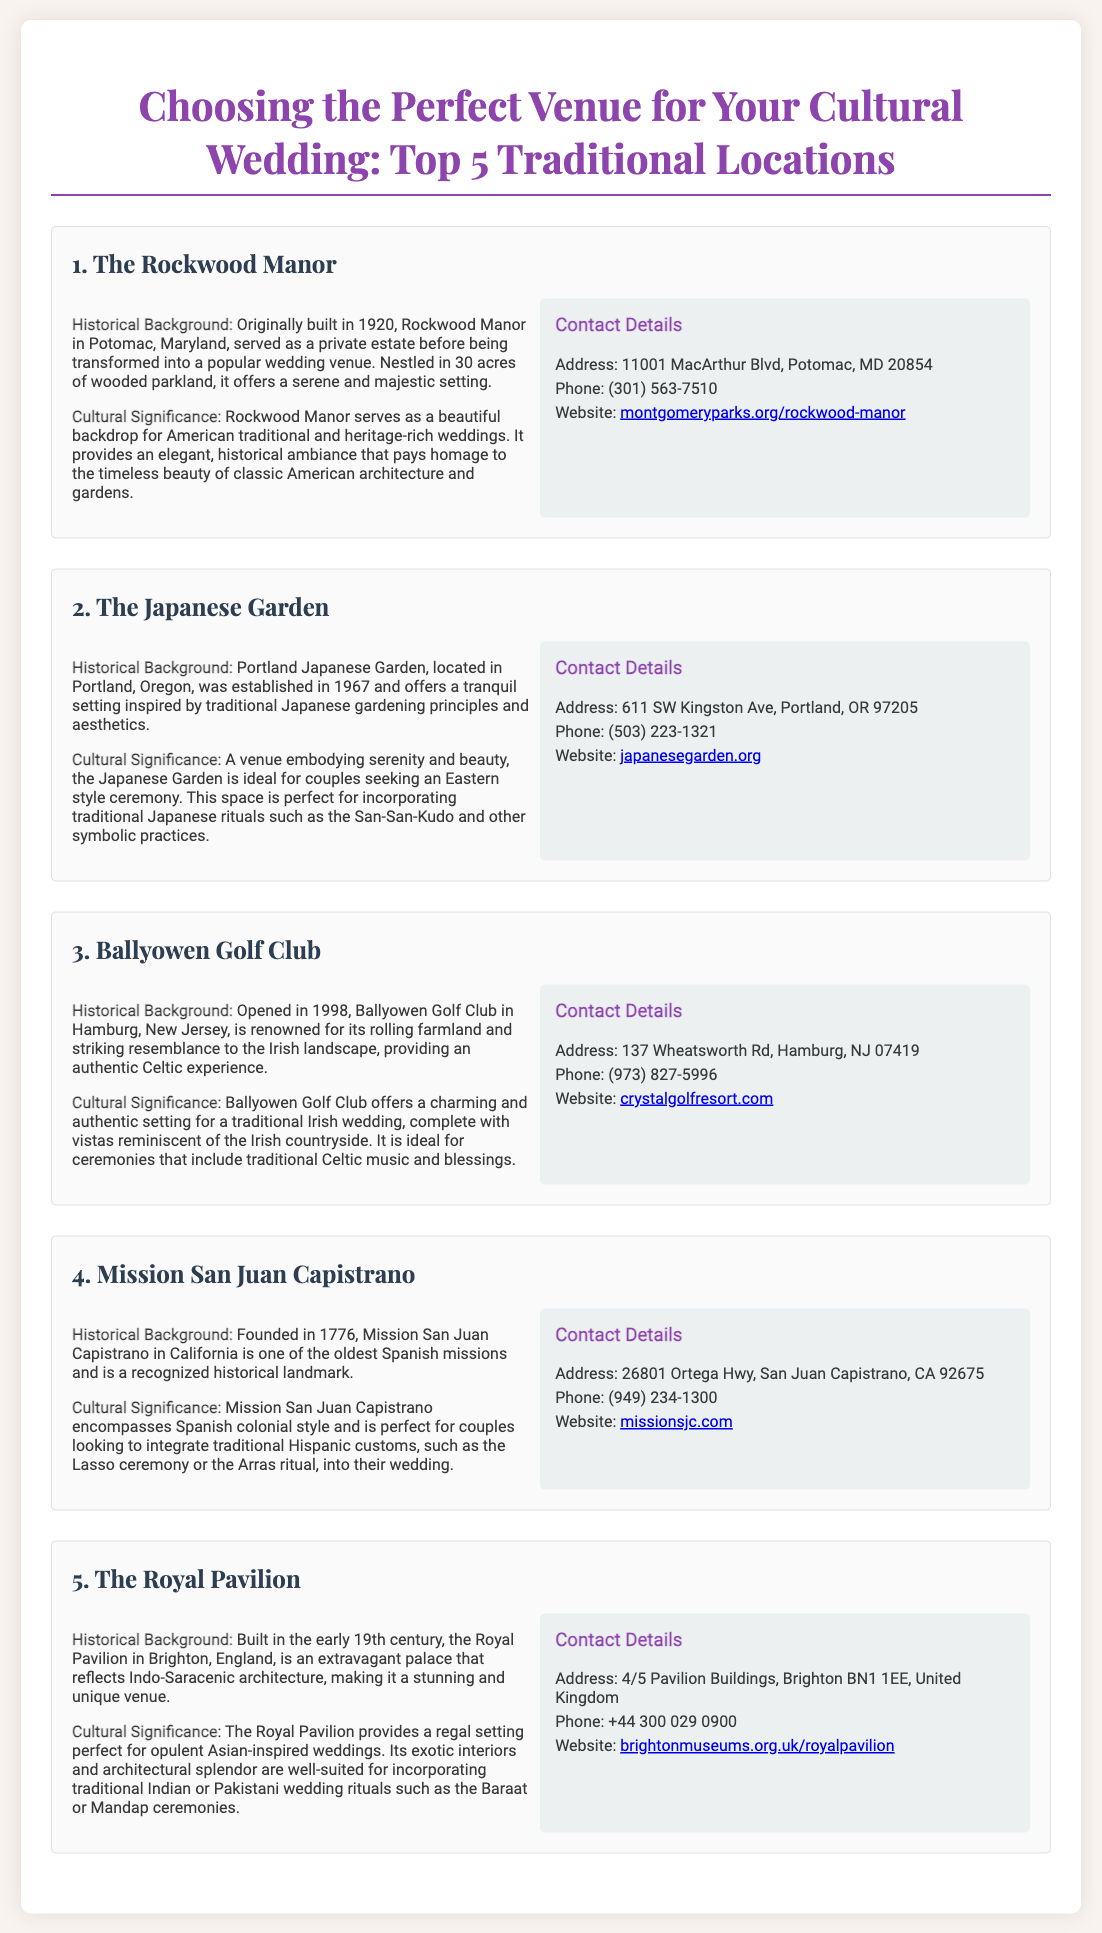What is the address of The Rockwood Manor? The address is found in the contact details section for The Rockwood Manor venue.
Answer: 11001 MacArthur Blvd, Potomac, MD 20854 What year was The Japanese Garden established? The year is mentioned in the historical background section of The Japanese Garden venue.
Answer: 1967 Which venue is ideal for incorporating traditional Japanese rituals? The document indicates that The Japanese Garden is perfect for traditional Japanese rituals such as the San-San-Kudo.
Answer: The Japanese Garden What is the cultural significance of Ballyowen Golf Club? The significance is described in the cultural significance section, relating to traditional Irish weddings.
Answer: A traditional Irish wedding How many acres does Rockwood Manor have? The document mentions that Rockwood Manor is nestled in 30 acres of wooded parkland.
Answer: 30 acres What phone number can be used to contact Mission San Juan Capistrano? The phone number is included in the contact details section for Mission San Juan Capistrano.
Answer: (949) 234-1300 What architectural style is the Royal Pavilion known for? The document describes the architectural style of the Royal Pavilion under historical background.
Answer: Indo-Saracenic Which venue was founded in 1776? The founding year is mentioned in the historical background of the Mission San Juan Capistrano venue.
Answer: Mission San Juan Capistrano Where is Ballyowen Golf Club located? The location is provided in the contact details of Ballyowen Golf Club.
Answer: Hamburg, New Jersey 